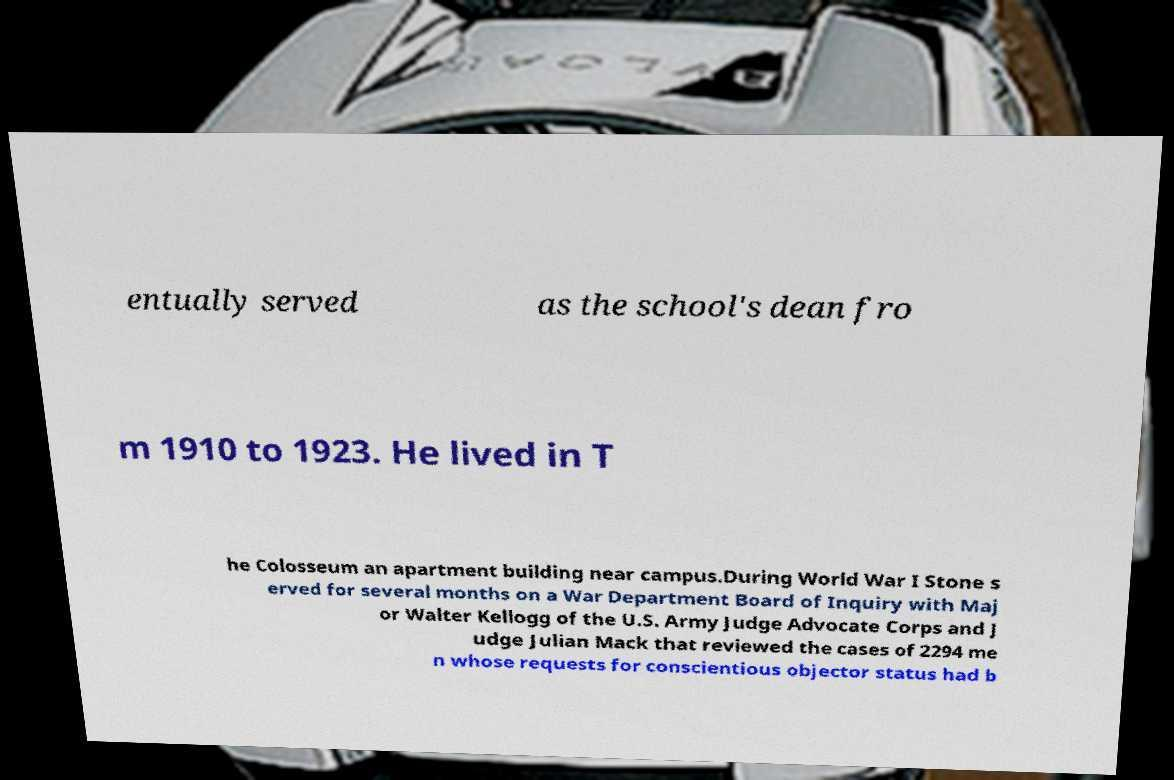Can you accurately transcribe the text from the provided image for me? entually served as the school's dean fro m 1910 to 1923. He lived in T he Colosseum an apartment building near campus.During World War I Stone s erved for several months on a War Department Board of Inquiry with Maj or Walter Kellogg of the U.S. Army Judge Advocate Corps and J udge Julian Mack that reviewed the cases of 2294 me n whose requests for conscientious objector status had b 